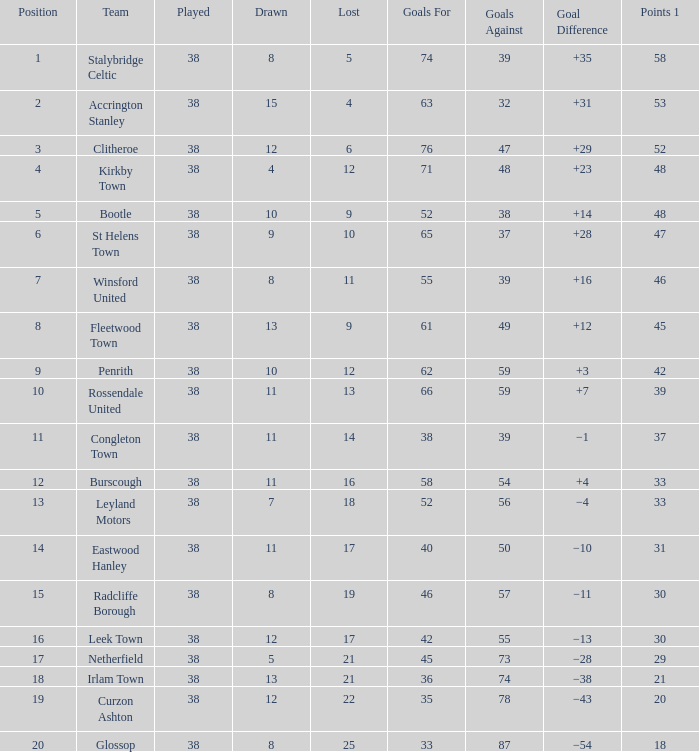What is the count of teams with 14 losses and fewer than 55 goals scored against them? 1.0. Help me parse the entirety of this table. {'header': ['Position', 'Team', 'Played', 'Drawn', 'Lost', 'Goals For', 'Goals Against', 'Goal Difference', 'Points 1'], 'rows': [['1', 'Stalybridge Celtic', '38', '8', '5', '74', '39', '+35', '58'], ['2', 'Accrington Stanley', '38', '15', '4', '63', '32', '+31', '53'], ['3', 'Clitheroe', '38', '12', '6', '76', '47', '+29', '52'], ['4', 'Kirkby Town', '38', '4', '12', '71', '48', '+23', '48'], ['5', 'Bootle', '38', '10', '9', '52', '38', '+14', '48'], ['6', 'St Helens Town', '38', '9', '10', '65', '37', '+28', '47'], ['7', 'Winsford United', '38', '8', '11', '55', '39', '+16', '46'], ['8', 'Fleetwood Town', '38', '13', '9', '61', '49', '+12', '45'], ['9', 'Penrith', '38', '10', '12', '62', '59', '+3', '42'], ['10', 'Rossendale United', '38', '11', '13', '66', '59', '+7', '39'], ['11', 'Congleton Town', '38', '11', '14', '38', '39', '−1', '37'], ['12', 'Burscough', '38', '11', '16', '58', '54', '+4', '33'], ['13', 'Leyland Motors', '38', '7', '18', '52', '56', '−4', '33'], ['14', 'Eastwood Hanley', '38', '11', '17', '40', '50', '−10', '31'], ['15', 'Radcliffe Borough', '38', '8', '19', '46', '57', '−11', '30'], ['16', 'Leek Town', '38', '12', '17', '42', '55', '−13', '30'], ['17', 'Netherfield', '38', '5', '21', '45', '73', '−28', '29'], ['18', 'Irlam Town', '38', '13', '21', '36', '74', '−38', '21'], ['19', 'Curzon Ashton', '38', '12', '22', '35', '78', '−43', '20'], ['20', 'Glossop', '38', '8', '25', '33', '87', '−54', '18']]} 